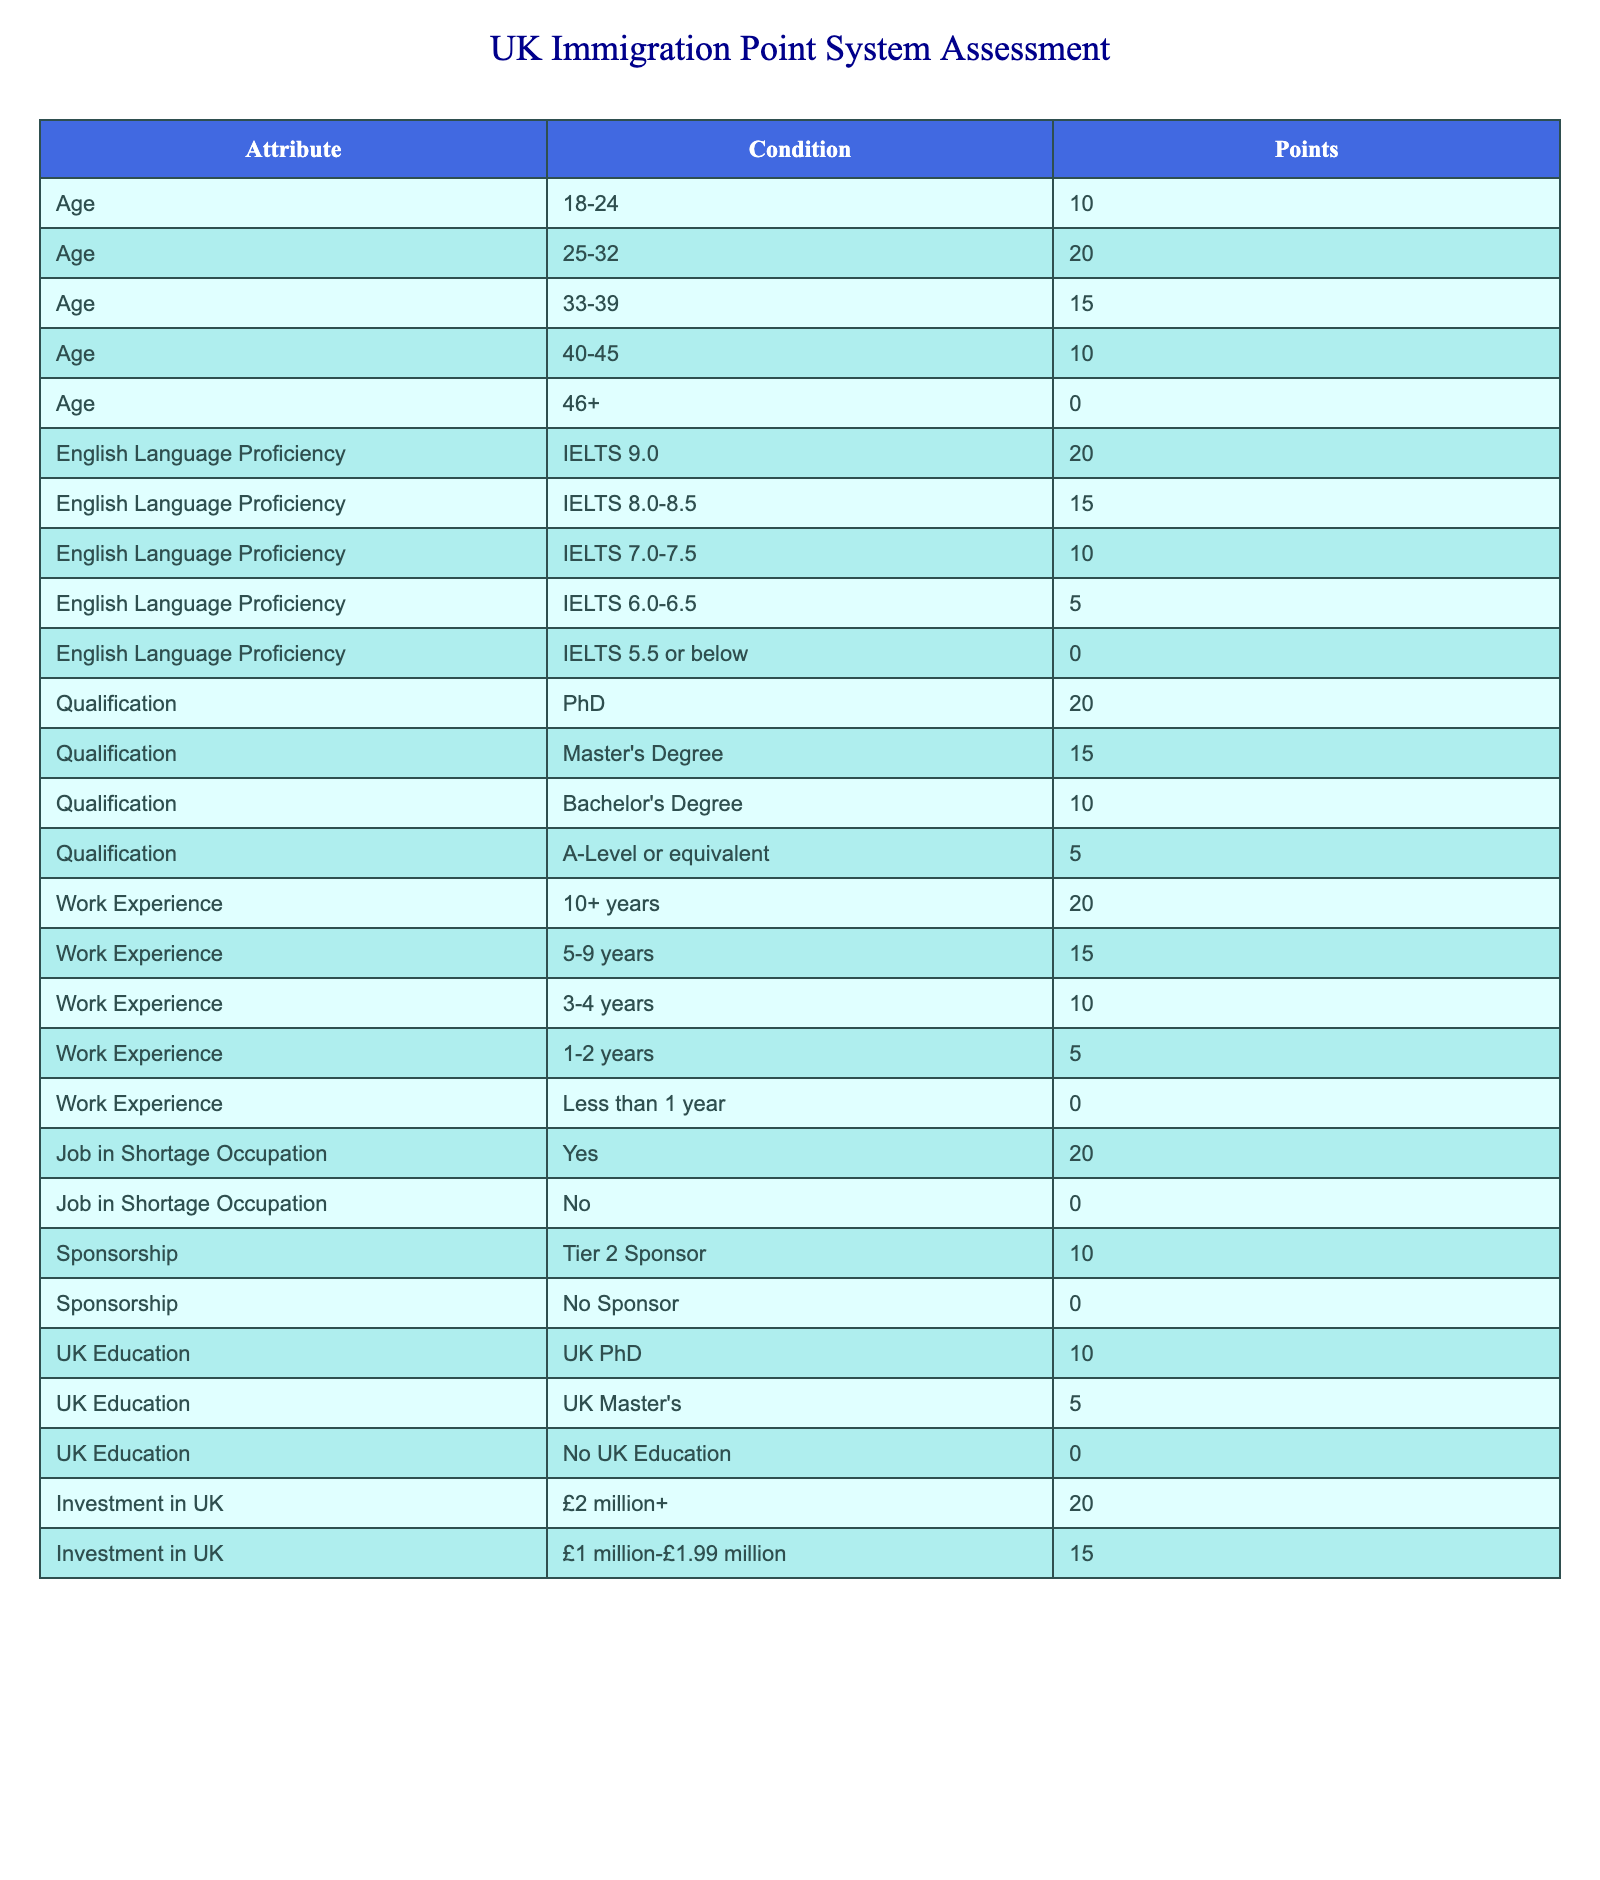What is the point value for someone aged 25-32? According to the table, the range for ages 25-32 provides 20 points.
Answer: 20 What points do you get for having a PhD? The table indicates that having a PhD qualifies for 20 points.
Answer: 20 If a candidate has 5 years of work experience and is applying for a job in a shortage occupation, how many points do they earn in total? The candidate receives 15 points for 5-9 years of work experience and 20 points for a job in a shortage occupation. Therefore, the total points are 15 + 20 = 35.
Answer: 35 Is a Tier 2 Sponsor required to gain any points in the Sponsorship category? The table shows that having a Tier 2 Sponsor provides 10 points, while having no sponsor gives 0 points. This means a Tier 2 Sponsor is indeed beneficial for points.
Answer: Yes What is the maximum number of points a candidate can earn if they have over 10 years of work experience and an IELTS score of 9.0? For over 10 years of work experience, they would earn 20 points, and for an IELTS score of 9.0, they would earn another 20 points. Therefore, the maximum points would be 20 + 20 = 40.
Answer: 40 Does a Bachelor’s Degree provide more points than having UK Education? A Bachelor’s Degree is worth 10 points, while having a UK Master's Degree earns 5 points and no UK Education earns 0 points. Since 10 is greater than both.
Answer: Yes How many points would a candidate earn if they invested £1.5 million in the UK, have an IELTS score of 7.5, and 3 years of work experience? The investment of £1.5 million does not fit into the provided options since it’s not listed. However, IELTS 7.0-7.5 provides 10 points and 3-4 years of work experience provides 10 points. Thus, the total would be 10 + 10 = 20 points, assuming the investment does not contribute additional points.
Answer: 20 What points would a 44-year-old candidate receive for a job in a shortage occupation, sponsorship, and a Bachelor’s degree? The points from the table indicate that a 44-year-old receives 10 points. A job in a shortage occupation provides 20 points, and a Bachelor's degree adds another 10 points. Therefore, the total points are 10 + 20 + 10 = 40.
Answer: 40 If someone has both a PhD and a job in a shortage occupation, how many points would they receive? According to the table, a PhD earns 20 points, while a job in a shortage occupation also earns 20 points. Therefore, the total points would be 20 + 20 = 40.
Answer: 40 